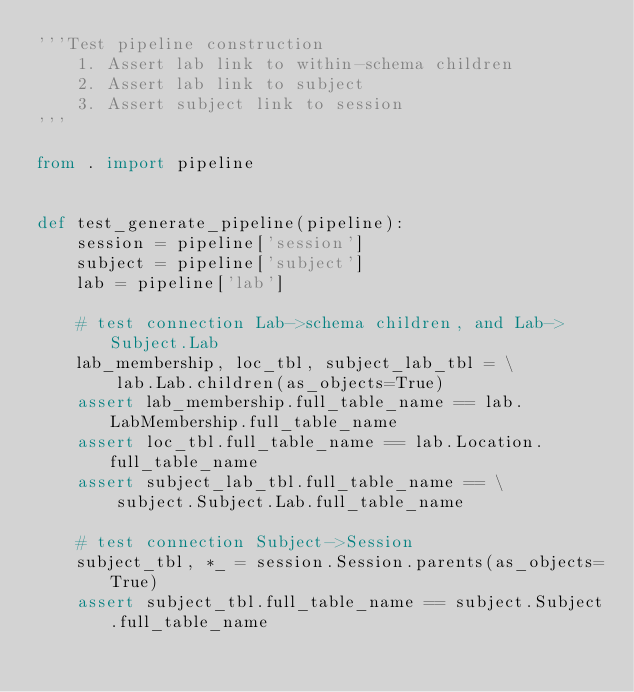<code> <loc_0><loc_0><loc_500><loc_500><_Python_>'''Test pipeline construction
    1. Assert lab link to within-schema children
    2. Assert lab link to subject
    3. Assert subject link to session
'''

from . import pipeline


def test_generate_pipeline(pipeline):
    session = pipeline['session']
    subject = pipeline['subject']
    lab = pipeline['lab']

    # test connection Lab->schema children, and Lab->Subject.Lab
    lab_membership, loc_tbl, subject_lab_tbl = \
        lab.Lab.children(as_objects=True)
    assert lab_membership.full_table_name == lab.LabMembership.full_table_name
    assert loc_tbl.full_table_name == lab.Location.full_table_name
    assert subject_lab_tbl.full_table_name == \
        subject.Subject.Lab.full_table_name

    # test connection Subject->Session
    subject_tbl, *_ = session.Session.parents(as_objects=True)
    assert subject_tbl.full_table_name == subject.Subject.full_table_name
</code> 